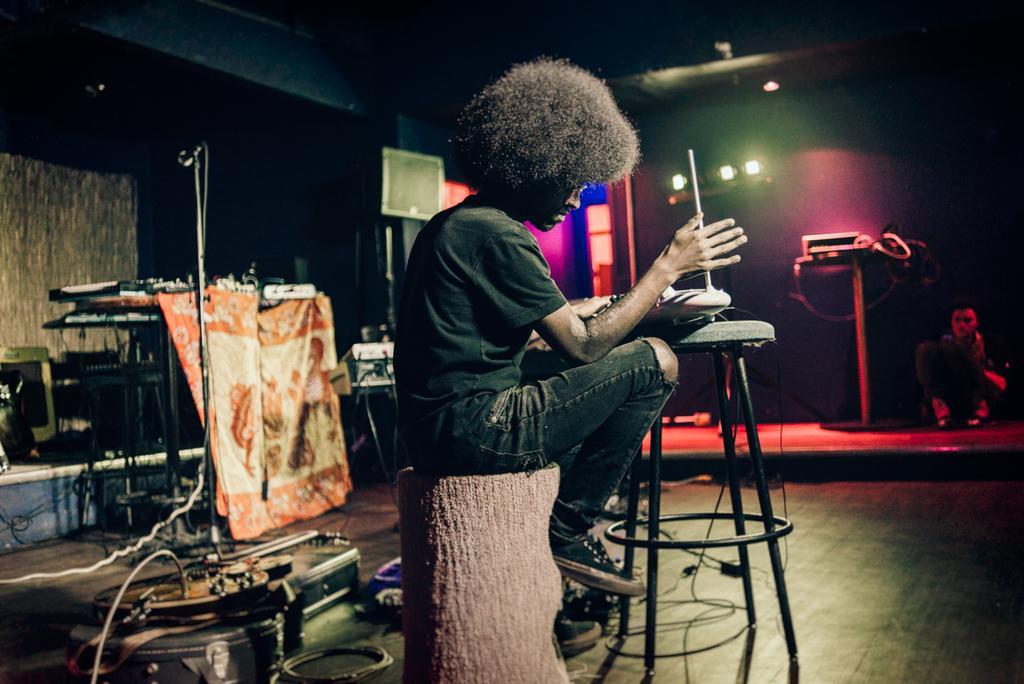How would you summarize this image in a sentence or two? In this image I can see a person wearing black color dress is sitting and holding an object in his hand. I can see a stool in front of him and few equipments on the floor. In the background I can see a microphone, few musical instruments, a person, few lights , few wires and the ceiling. 